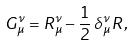Convert formula to latex. <formula><loc_0><loc_0><loc_500><loc_500>G _ { \mu } ^ { \nu } = R _ { \mu } ^ { \nu } - \frac { 1 } { 2 } \, \delta _ { \mu } ^ { \nu } \, R ,</formula> 